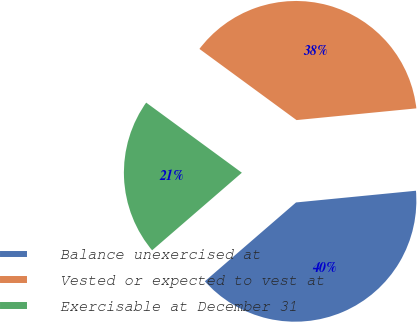Convert chart. <chart><loc_0><loc_0><loc_500><loc_500><pie_chart><fcel>Balance unexercised at<fcel>Vested or expected to vest at<fcel>Exercisable at December 31<nl><fcel>40.2%<fcel>38.38%<fcel>21.41%<nl></chart> 